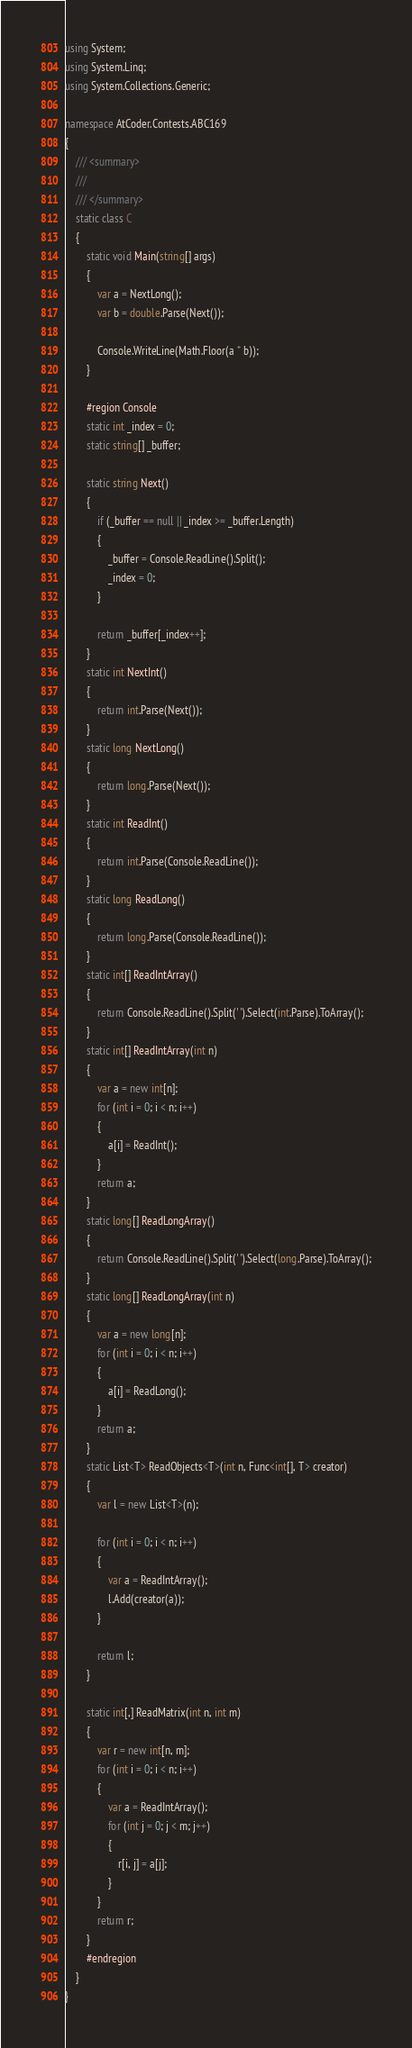Convert code to text. <code><loc_0><loc_0><loc_500><loc_500><_C#_>using System;
using System.Linq;
using System.Collections.Generic;

namespace AtCoder.Contests.ABC169
{
    /// <summary>
    /// 
    /// </summary>
    static class C
    {
        static void Main(string[] args)
        {
            var a = NextLong();
            var b = double.Parse(Next());

            Console.WriteLine(Math.Floor(a * b));
        }

        #region Console
        static int _index = 0;
        static string[] _buffer;

        static string Next()
        {
            if (_buffer == null || _index >= _buffer.Length)
            {
                _buffer = Console.ReadLine().Split();
                _index = 0;
            }

            return _buffer[_index++];
        }
        static int NextInt()
        {
            return int.Parse(Next());
        }
        static long NextLong()
        {
            return long.Parse(Next());
        }
        static int ReadInt()
        {
            return int.Parse(Console.ReadLine());
        }
        static long ReadLong()
        {
            return long.Parse(Console.ReadLine());
        }
        static int[] ReadIntArray()
        {
            return Console.ReadLine().Split(' ').Select(int.Parse).ToArray();
        }
        static int[] ReadIntArray(int n)
        {
            var a = new int[n];
            for (int i = 0; i < n; i++)
            {
                a[i] = ReadInt();
            }
            return a;
        }
        static long[] ReadLongArray()
        {
            return Console.ReadLine().Split(' ').Select(long.Parse).ToArray();
        }
        static long[] ReadLongArray(int n)
        {
            var a = new long[n];
            for (int i = 0; i < n; i++)
            {
                a[i] = ReadLong();
            }
            return a;
        }
        static List<T> ReadObjects<T>(int n, Func<int[], T> creator)
        {
            var l = new List<T>(n);

            for (int i = 0; i < n; i++)
            {
                var a = ReadIntArray();
                l.Add(creator(a));
            }

            return l;
        }

        static int[,] ReadMatrix(int n, int m)
        {
            var r = new int[n, m];
            for (int i = 0; i < n; i++)
            {
                var a = ReadIntArray();
                for (int j = 0; j < m; j++)
                {
                    r[i, j] = a[j];
                }
            }
            return r;
        }
        #endregion
    }
}
</code> 